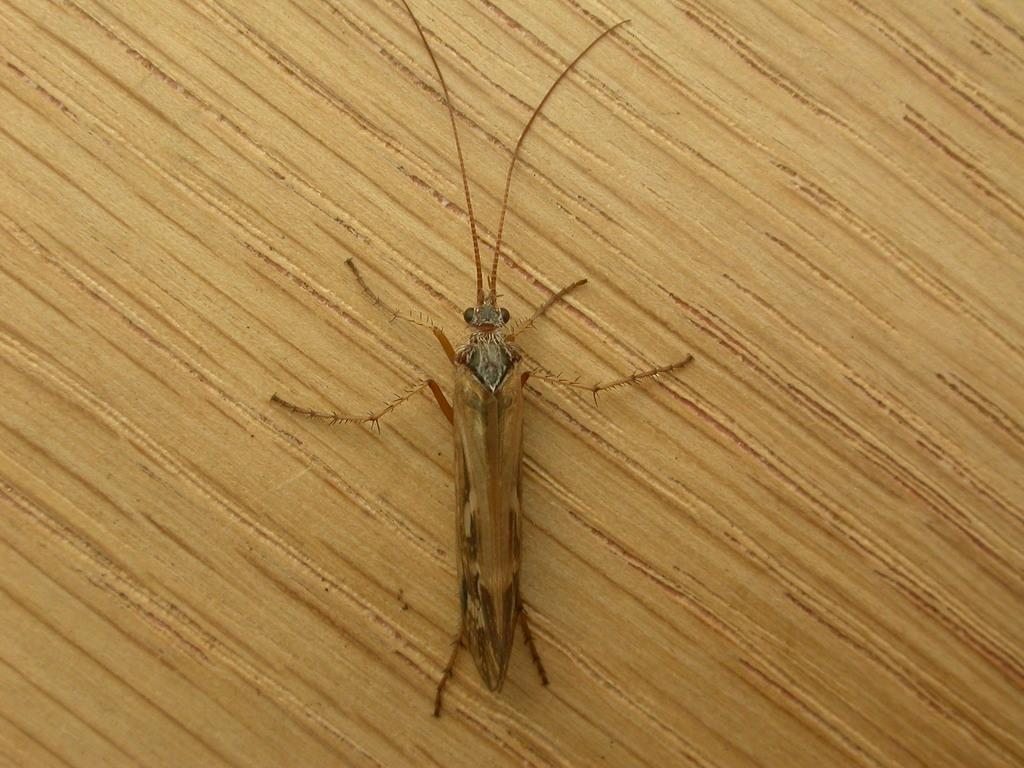What type of creature can be seen in the image? There is an insect in the image. What is the insect resting on in the image? The insect is on a wooden surface. Where is the insect located in relation to the image? The insect is located in the center of the image. What type of popcorn is being served in the chairs in the image? There are no chairs, popcorn, or references to serving in the image; it features an insect on a wooden surface. 